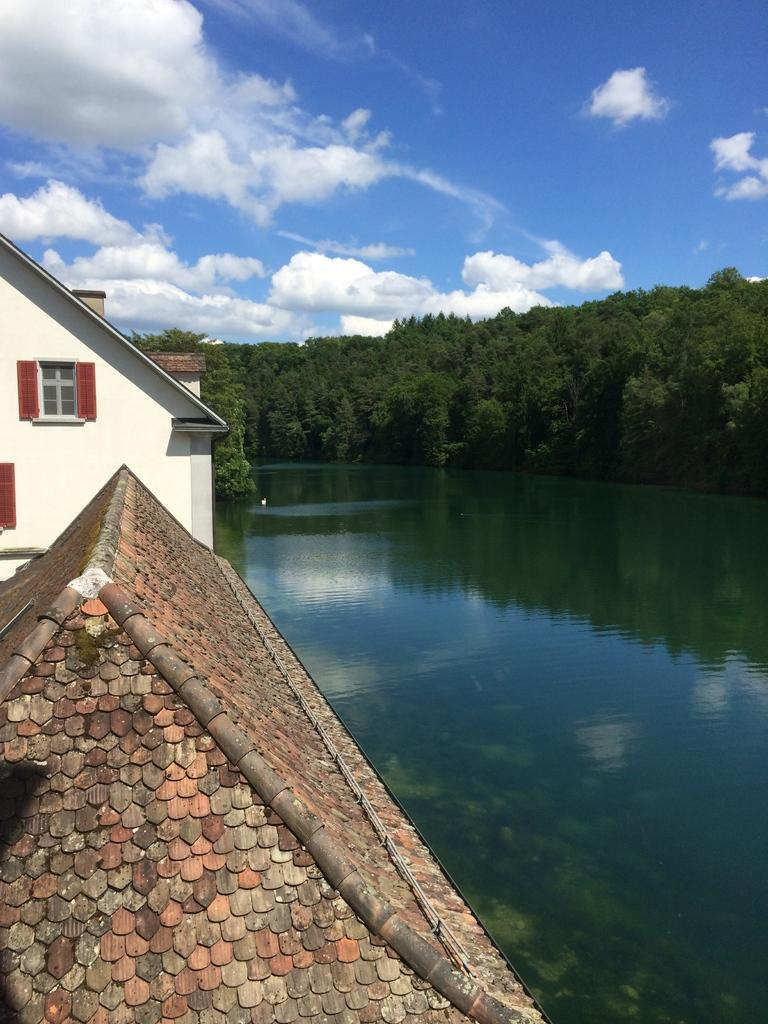What type of structures can be seen in the image? There are houses in the image. What feature do the houses have? The houses have windows. What natural element is visible in the image? There is water visible in the image. What type of vegetation is present in the image? There are green color trees in the image. What is the color of the sky in the image? The sky is blue and white in color. What is the degree of pleasure experienced by the trees in the image? There is no indication of pleasure or any emotions in the image, as trees are inanimate objects and cannot experience emotions. 